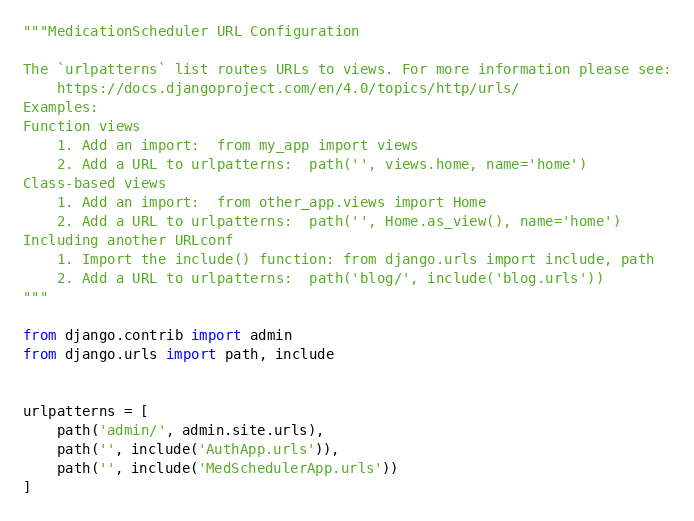<code> <loc_0><loc_0><loc_500><loc_500><_Python_>"""MedicationScheduler URL Configuration

The `urlpatterns` list routes URLs to views. For more information please see:
    https://docs.djangoproject.com/en/4.0/topics/http/urls/
Examples:
Function views
    1. Add an import:  from my_app import views
    2. Add a URL to urlpatterns:  path('', views.home, name='home')
Class-based views
    1. Add an import:  from other_app.views import Home
    2. Add a URL to urlpatterns:  path('', Home.as_view(), name='home')
Including another URLconf
    1. Import the include() function: from django.urls import include, path
    2. Add a URL to urlpatterns:  path('blog/', include('blog.urls'))
"""

from django.contrib import admin
from django.urls import path, include


urlpatterns = [
    path('admin/', admin.site.urls),
    path('', include('AuthApp.urls')),
    path('', include('MedSchedulerApp.urls'))
]
</code> 